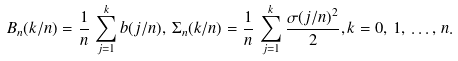<formula> <loc_0><loc_0><loc_500><loc_500>B _ { n } ( k / n ) = \frac { 1 } { n } \, \sum _ { j = 1 } ^ { k } b ( j / n ) , \, \Sigma _ { n } ( k / n ) = \frac { 1 } { n } \, \sum _ { j = 1 } ^ { k } \frac { \sigma ( j / n ) ^ { 2 } } { 2 } , k = 0 , \, 1 , \, \dots , \, n .</formula> 